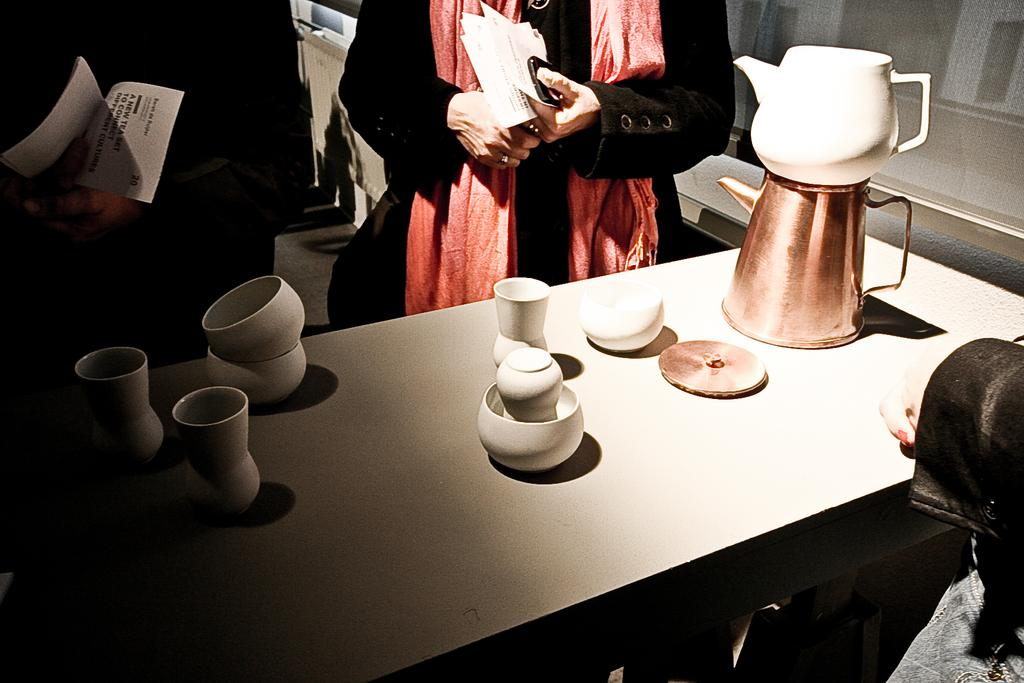What is on the table in the image? There is a bowl, cups, and a jar on the table in the image. What are the persons standing near the table doing? The persons standing near the table are holding papers. How many objects can be seen on the table? There are three objects on the table: a bowl, cups, and a jar. What type of oil is being drained from the alley in the image? There is no alley, oil, or drain present in the image. What type of creature might be found in the alley in the image? There is no alley or creature present in the image. 